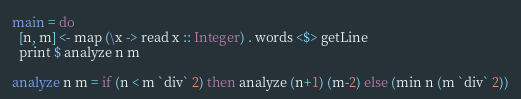Convert code to text. <code><loc_0><loc_0><loc_500><loc_500><_Haskell_>
main = do
  [n, m] <- map (\x -> read x :: Integer) . words <$> getLine 
  print $ analyze n m

analyze n m = if (n < m `div` 2) then analyze (n+1) (m-2) else (min n (m `div` 2))
</code> 